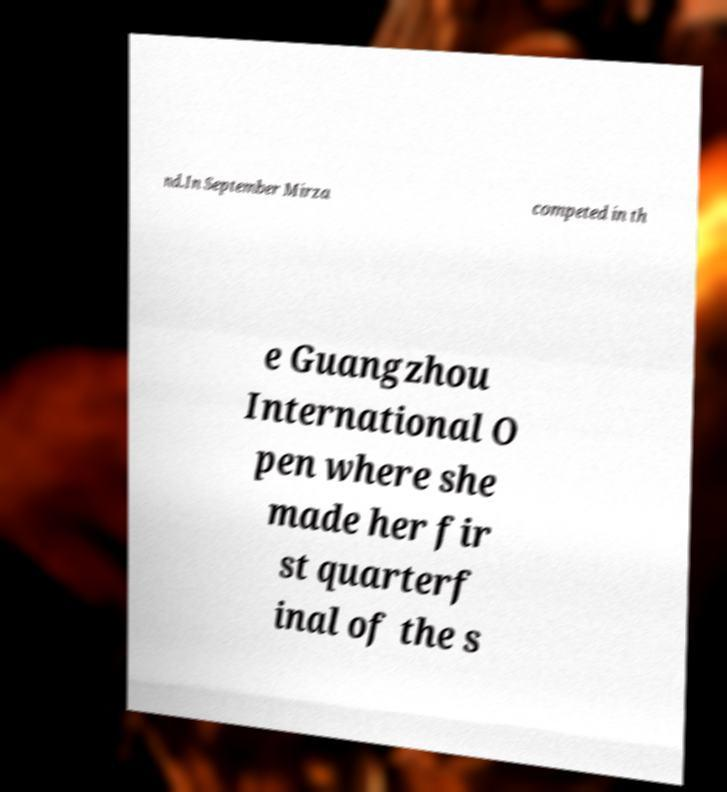I need the written content from this picture converted into text. Can you do that? nd.In September Mirza competed in th e Guangzhou International O pen where she made her fir st quarterf inal of the s 